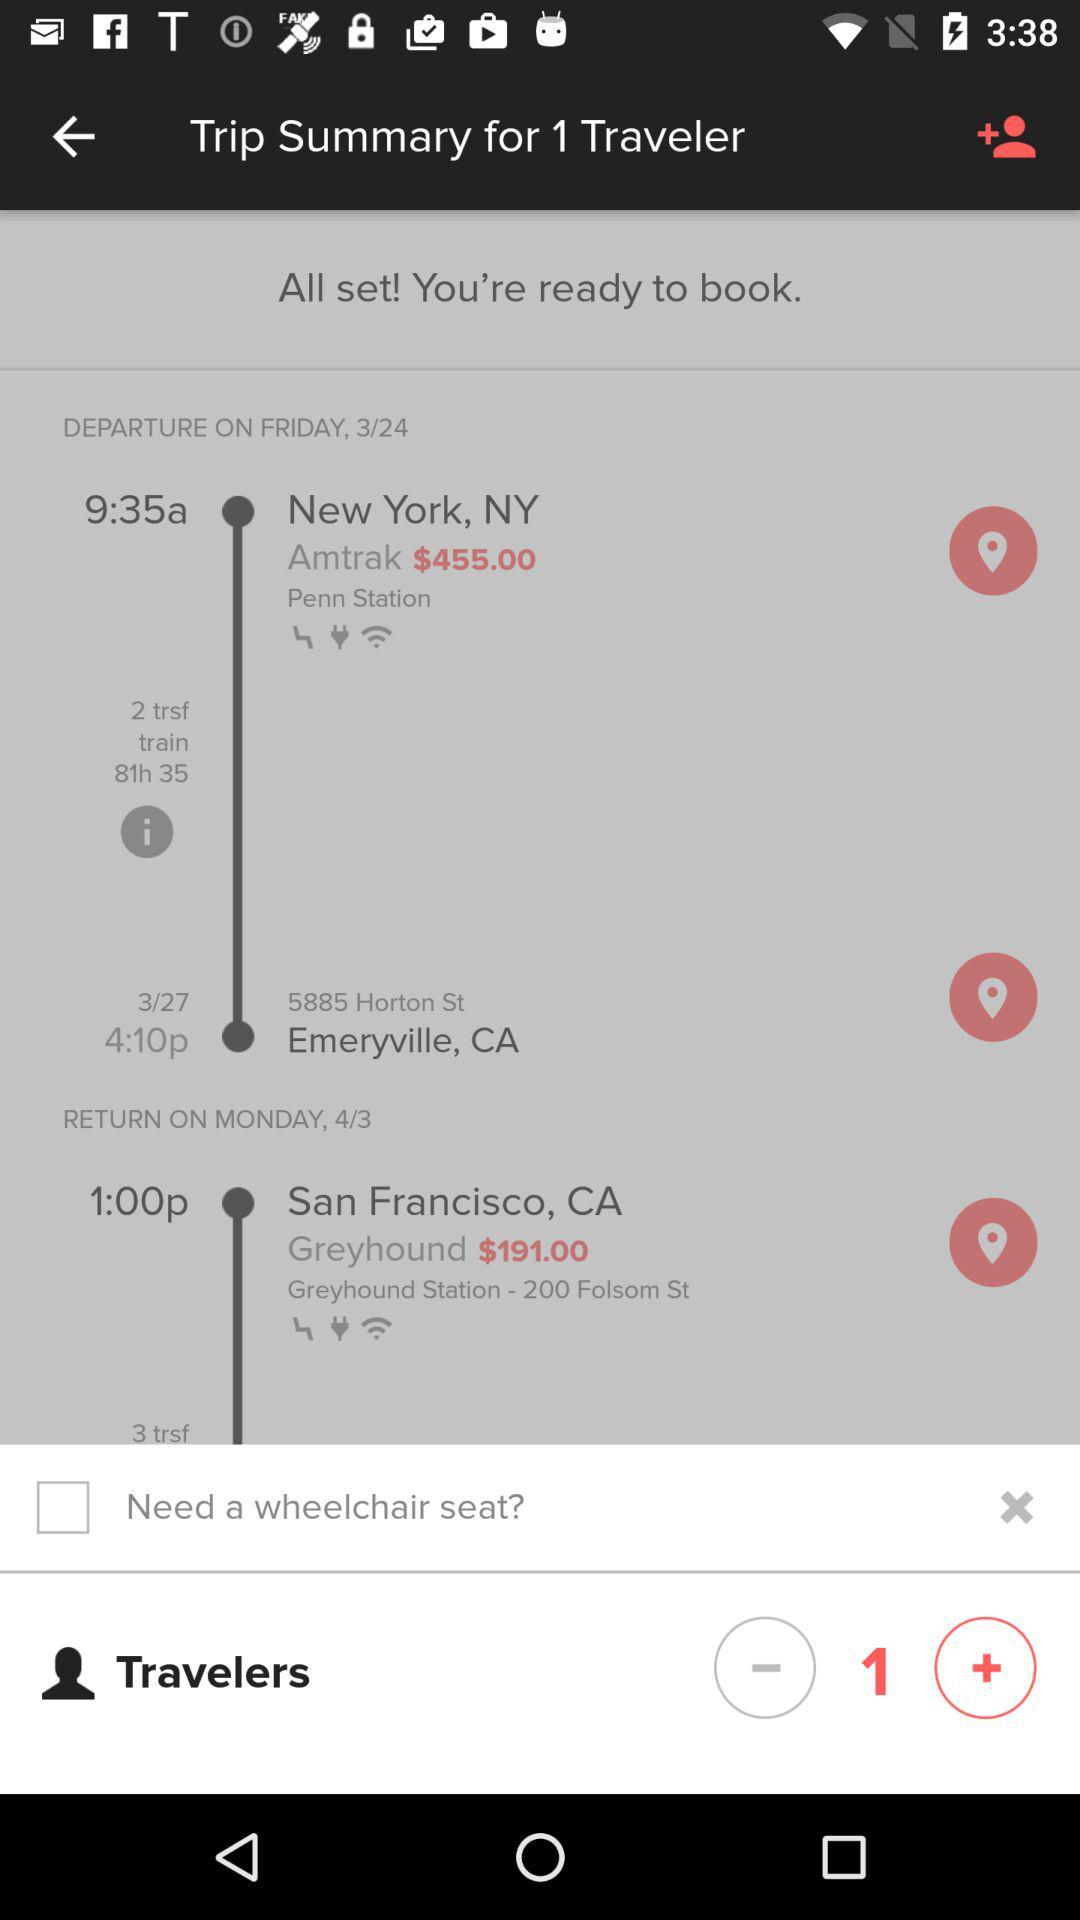What is the day on the given date of departure? The day on the given date of departure is Friday. 